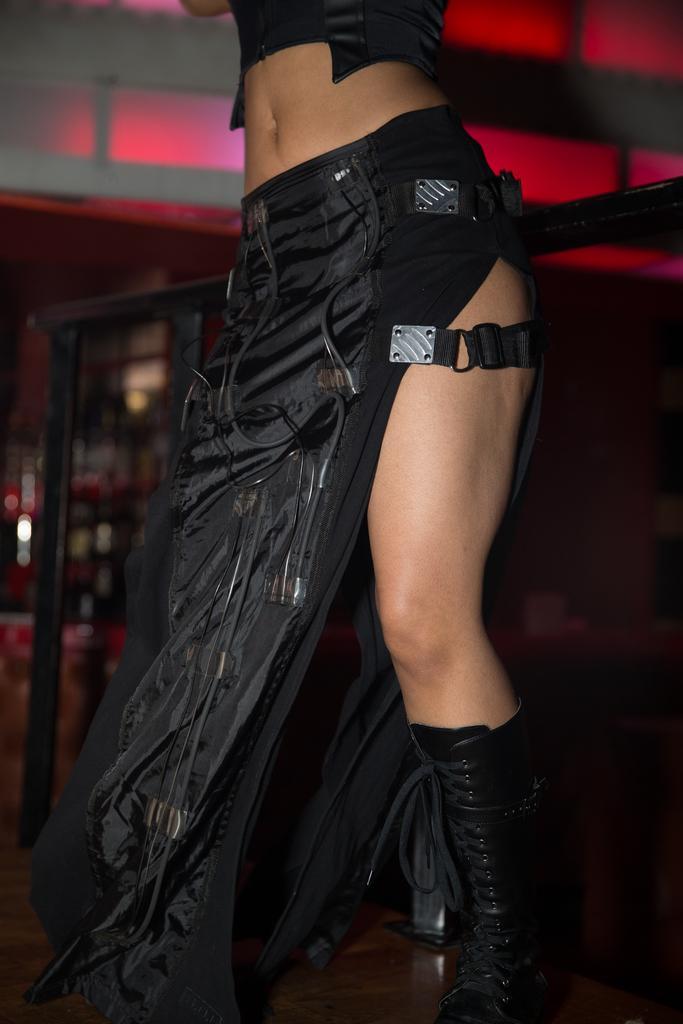Can you describe this image briefly? In this image we can see a person. In the background there is a wall. 